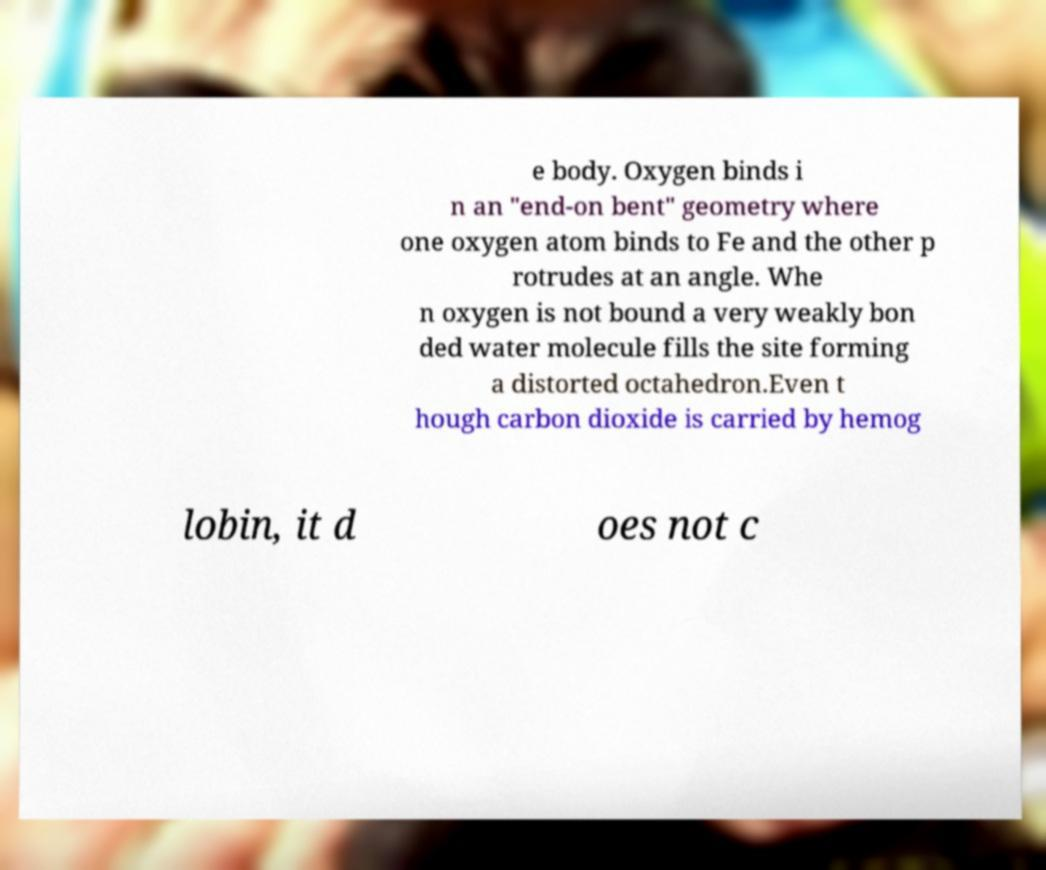Can you read and provide the text displayed in the image?This photo seems to have some interesting text. Can you extract and type it out for me? e body. Oxygen binds i n an "end-on bent" geometry where one oxygen atom binds to Fe and the other p rotrudes at an angle. Whe n oxygen is not bound a very weakly bon ded water molecule fills the site forming a distorted octahedron.Even t hough carbon dioxide is carried by hemog lobin, it d oes not c 